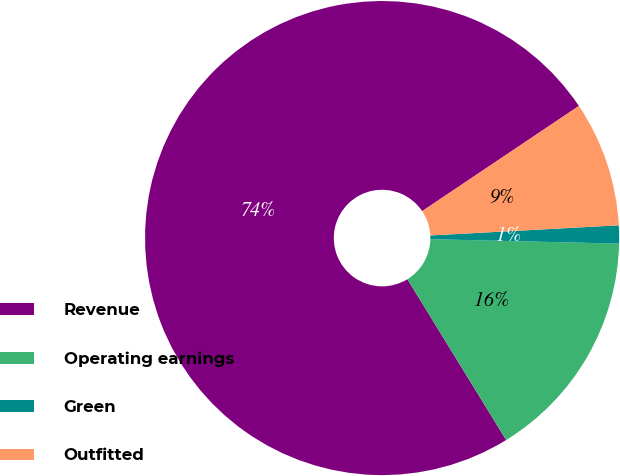Convert chart to OTSL. <chart><loc_0><loc_0><loc_500><loc_500><pie_chart><fcel>Revenue<fcel>Operating earnings<fcel>Green<fcel>Outfitted<nl><fcel>74.36%<fcel>15.86%<fcel>1.23%<fcel>8.55%<nl></chart> 